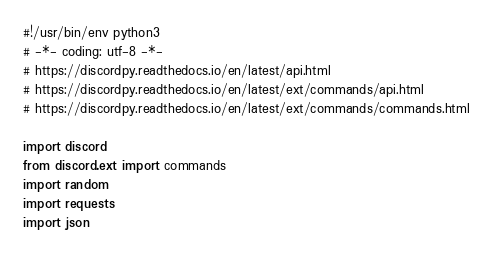Convert code to text. <code><loc_0><loc_0><loc_500><loc_500><_Python_>#!/usr/bin/env python3
# -*- coding: utf-8 -*-
# https://discordpy.readthedocs.io/en/latest/api.html
# https://discordpy.readthedocs.io/en/latest/ext/commands/api.html
# https://discordpy.readthedocs.io/en/latest/ext/commands/commands.html

import discord
from discord.ext import commands
import random
import requests
import json
</code> 